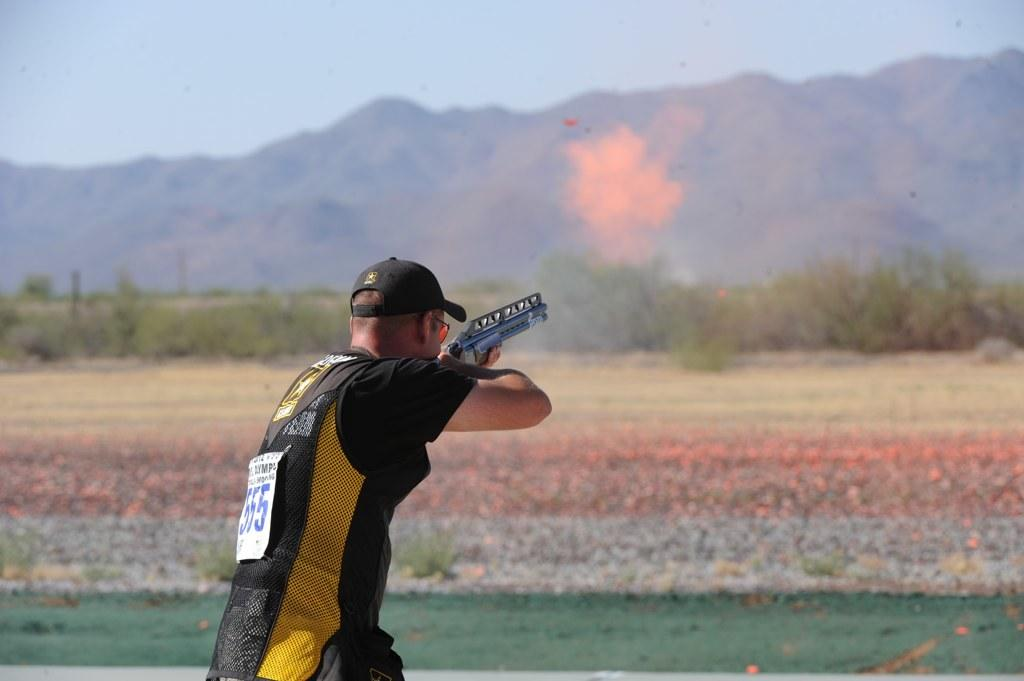What is the main subject of the image? There is a person in the image. What is the person holding in the image? The person is holding a gun. What can be seen in the background of the image? There are trees, mountains, and the sky visible in the background of the image. What type of cactus can be seen blowing in the wind in the image? There is no cactus or wind present in the image; it features a person holding a gun with a background of trees, mountains, and the sky. 